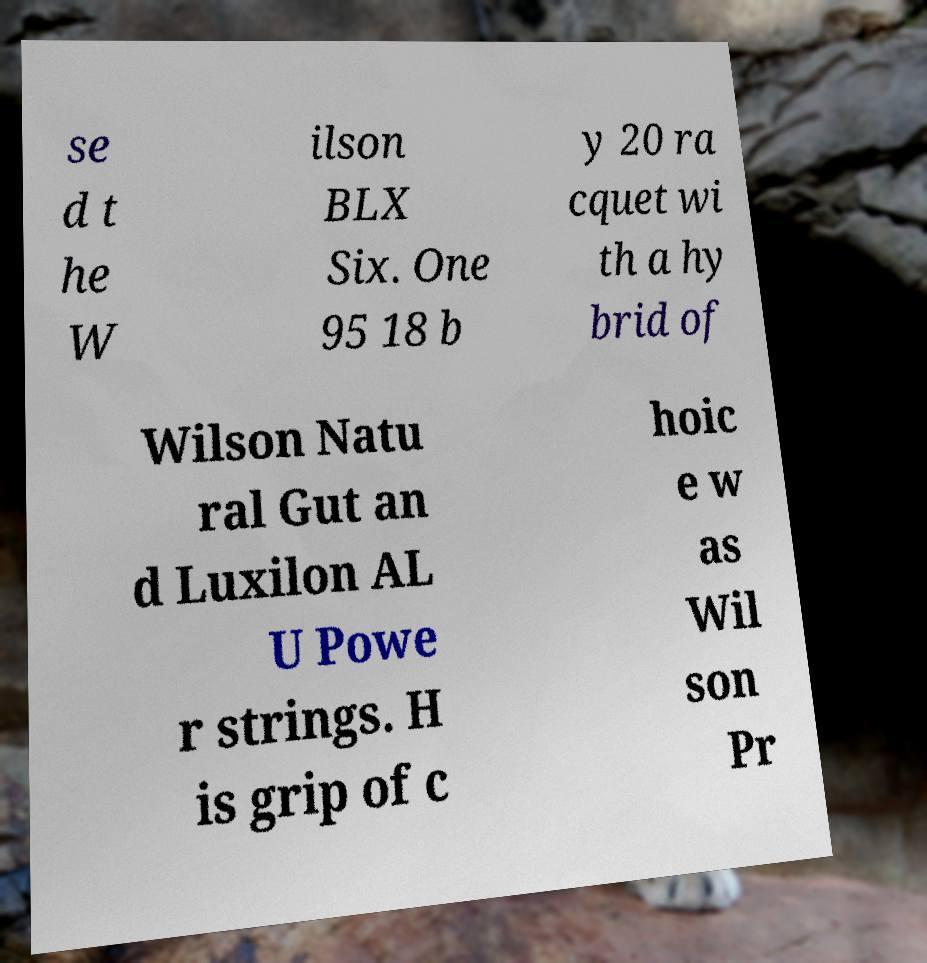For documentation purposes, I need the text within this image transcribed. Could you provide that? se d t he W ilson BLX Six. One 95 18 b y 20 ra cquet wi th a hy brid of Wilson Natu ral Gut an d Luxilon AL U Powe r strings. H is grip of c hoic e w as Wil son Pr 